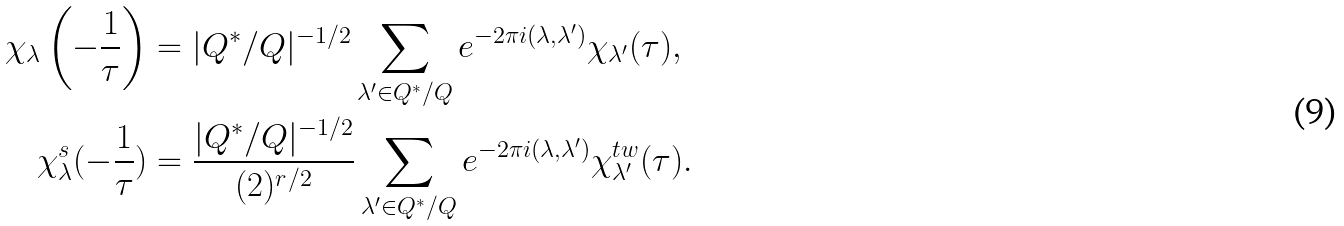Convert formula to latex. <formula><loc_0><loc_0><loc_500><loc_500>\chi _ { \lambda } \left ( - \frac { 1 } { \tau } \right ) & = | Q ^ { * } / Q | ^ { - 1 / 2 } \sum _ { \lambda ^ { \prime } \in Q ^ { * } / Q } e ^ { - 2 \pi i ( \lambda , \lambda ^ { \prime } ) } \chi _ { \lambda ^ { \prime } } ( \tau ) , \\ \chi _ { \lambda } ^ { s } ( - \frac { 1 } { \tau } ) & = \frac { | Q ^ { * } / Q | ^ { - 1 / 2 } } { ( 2 ) ^ { r / 2 } } \sum _ { \lambda ^ { \prime } \in Q ^ { * } / Q } e ^ { - 2 \pi i ( \lambda , \lambda ^ { \prime } ) } \chi _ { \lambda ^ { \prime } } ^ { t w } ( \tau ) .</formula> 